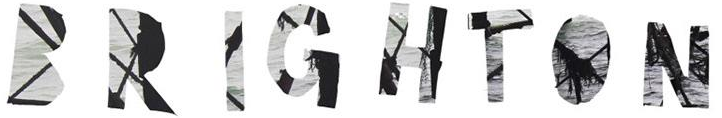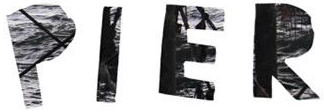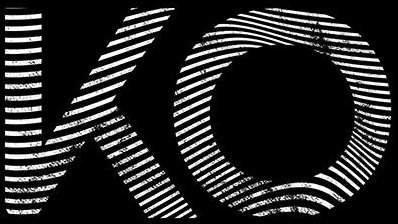What words are shown in these images in order, separated by a semicolon? BRIGHTON; PIER; KO 